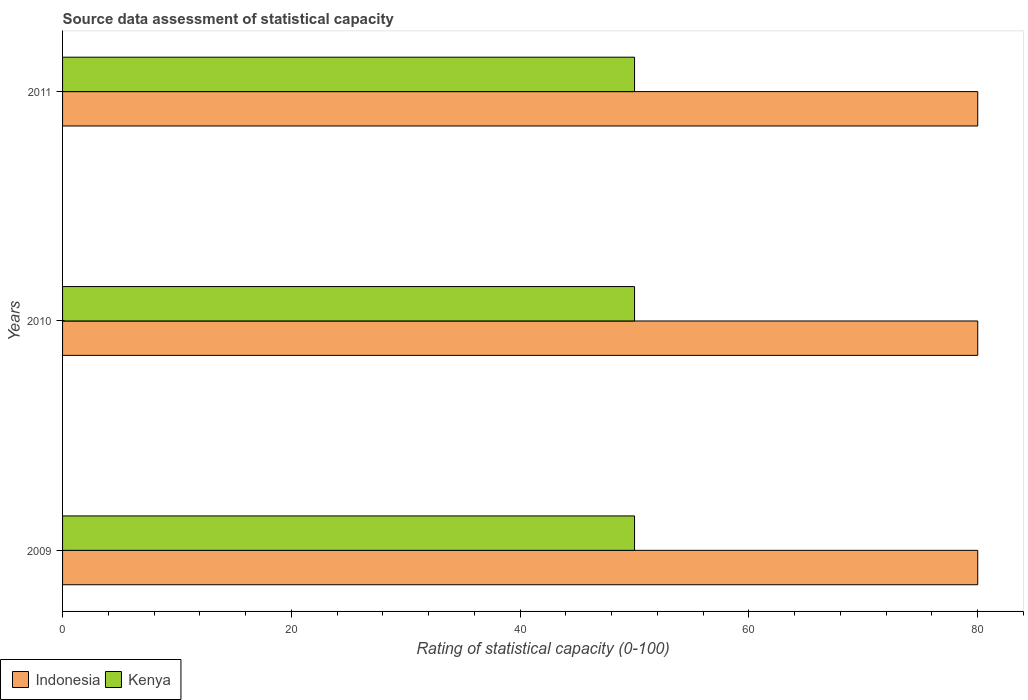How many different coloured bars are there?
Keep it short and to the point. 2. How many groups of bars are there?
Your answer should be very brief. 3. Are the number of bars per tick equal to the number of legend labels?
Your answer should be very brief. Yes. Are the number of bars on each tick of the Y-axis equal?
Keep it short and to the point. Yes. How many bars are there on the 1st tick from the bottom?
Make the answer very short. 2. In how many cases, is the number of bars for a given year not equal to the number of legend labels?
Keep it short and to the point. 0. What is the rating of statistical capacity in Kenya in 2009?
Your answer should be very brief. 50. Across all years, what is the maximum rating of statistical capacity in Kenya?
Provide a short and direct response. 50. Across all years, what is the minimum rating of statistical capacity in Kenya?
Offer a terse response. 50. In which year was the rating of statistical capacity in Kenya maximum?
Keep it short and to the point. 2009. What is the total rating of statistical capacity in Kenya in the graph?
Provide a succinct answer. 150. What is the difference between the rating of statistical capacity in Indonesia in 2010 and the rating of statistical capacity in Kenya in 2011?
Provide a short and direct response. 30. What is the average rating of statistical capacity in Kenya per year?
Provide a succinct answer. 50. In the year 2009, what is the difference between the rating of statistical capacity in Kenya and rating of statistical capacity in Indonesia?
Ensure brevity in your answer.  -30. What is the ratio of the rating of statistical capacity in Kenya in 2009 to that in 2010?
Your answer should be very brief. 1. Is the rating of statistical capacity in Kenya in 2009 less than that in 2011?
Your answer should be compact. No. Is the difference between the rating of statistical capacity in Kenya in 2009 and 2010 greater than the difference between the rating of statistical capacity in Indonesia in 2009 and 2010?
Make the answer very short. No. What is the difference between the highest and the second highest rating of statistical capacity in Kenya?
Your answer should be compact. 0. What is the difference between the highest and the lowest rating of statistical capacity in Indonesia?
Provide a succinct answer. 0. Is the sum of the rating of statistical capacity in Kenya in 2009 and 2010 greater than the maximum rating of statistical capacity in Indonesia across all years?
Offer a very short reply. Yes. What does the 2nd bar from the top in 2009 represents?
Provide a short and direct response. Indonesia. What does the 2nd bar from the bottom in 2011 represents?
Your answer should be very brief. Kenya. Are all the bars in the graph horizontal?
Provide a short and direct response. Yes. Are the values on the major ticks of X-axis written in scientific E-notation?
Make the answer very short. No. Does the graph contain grids?
Keep it short and to the point. No. How many legend labels are there?
Keep it short and to the point. 2. How are the legend labels stacked?
Make the answer very short. Horizontal. What is the title of the graph?
Your answer should be very brief. Source data assessment of statistical capacity. Does "Jordan" appear as one of the legend labels in the graph?
Provide a succinct answer. No. What is the label or title of the X-axis?
Your response must be concise. Rating of statistical capacity (0-100). What is the Rating of statistical capacity (0-100) in Kenya in 2009?
Provide a short and direct response. 50. What is the Rating of statistical capacity (0-100) of Indonesia in 2010?
Give a very brief answer. 80. What is the Rating of statistical capacity (0-100) in Indonesia in 2011?
Offer a terse response. 80. Across all years, what is the maximum Rating of statistical capacity (0-100) in Indonesia?
Provide a succinct answer. 80. Across all years, what is the maximum Rating of statistical capacity (0-100) in Kenya?
Keep it short and to the point. 50. Across all years, what is the minimum Rating of statistical capacity (0-100) of Kenya?
Ensure brevity in your answer.  50. What is the total Rating of statistical capacity (0-100) in Indonesia in the graph?
Your answer should be very brief. 240. What is the total Rating of statistical capacity (0-100) of Kenya in the graph?
Provide a short and direct response. 150. What is the difference between the Rating of statistical capacity (0-100) of Kenya in 2009 and that in 2011?
Make the answer very short. 0. What is the difference between the Rating of statistical capacity (0-100) in Indonesia in 2010 and that in 2011?
Give a very brief answer. 0. What is the difference between the Rating of statistical capacity (0-100) in Kenya in 2010 and that in 2011?
Make the answer very short. 0. What is the difference between the Rating of statistical capacity (0-100) of Indonesia in 2009 and the Rating of statistical capacity (0-100) of Kenya in 2011?
Your response must be concise. 30. What is the average Rating of statistical capacity (0-100) in Indonesia per year?
Your answer should be compact. 80. What is the average Rating of statistical capacity (0-100) in Kenya per year?
Give a very brief answer. 50. What is the ratio of the Rating of statistical capacity (0-100) in Kenya in 2009 to that in 2010?
Make the answer very short. 1. What is the difference between the highest and the lowest Rating of statistical capacity (0-100) in Indonesia?
Ensure brevity in your answer.  0. What is the difference between the highest and the lowest Rating of statistical capacity (0-100) in Kenya?
Your answer should be very brief. 0. 